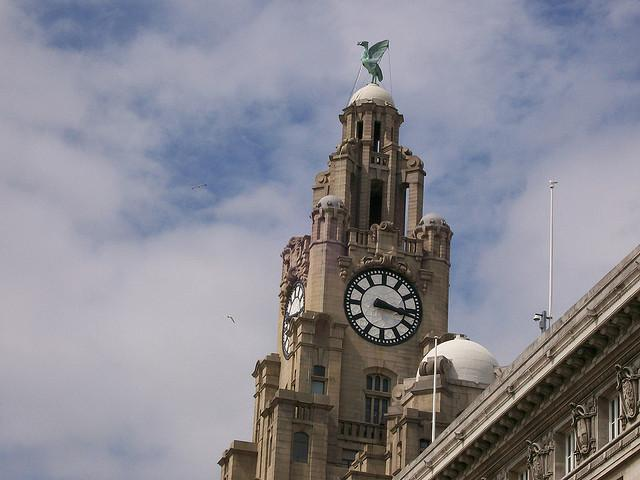Why are there ropes on the statue?

Choices:
A) moving it
B) theft
C) stability
D) design stability 